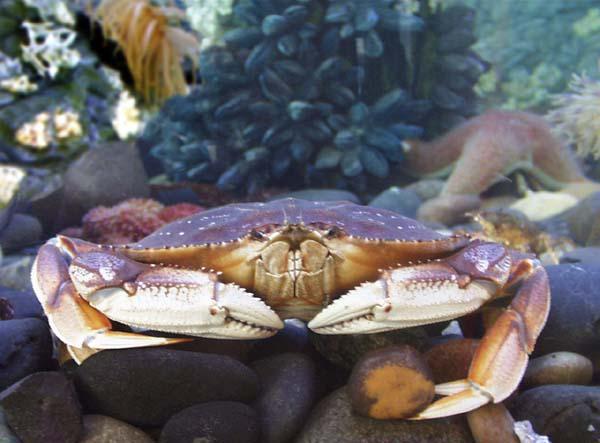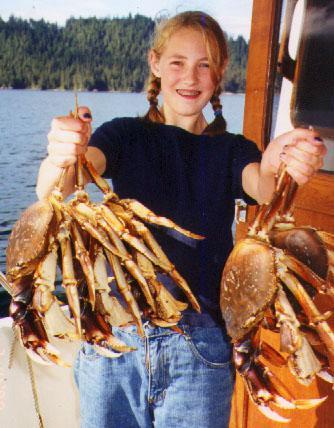The first image is the image on the left, the second image is the image on the right. For the images displayed, is the sentence "In one image, a person wearing a front-brimmed hat and jacket is holding a single large crab with its legs outstretched." factually correct? Answer yes or no. No. The first image is the image on the left, the second image is the image on the right. Assess this claim about the two images: "The right image features a person in a ball cap holding up a purple crab with the bare hand of the arm on the left.". Correct or not? Answer yes or no. No. 